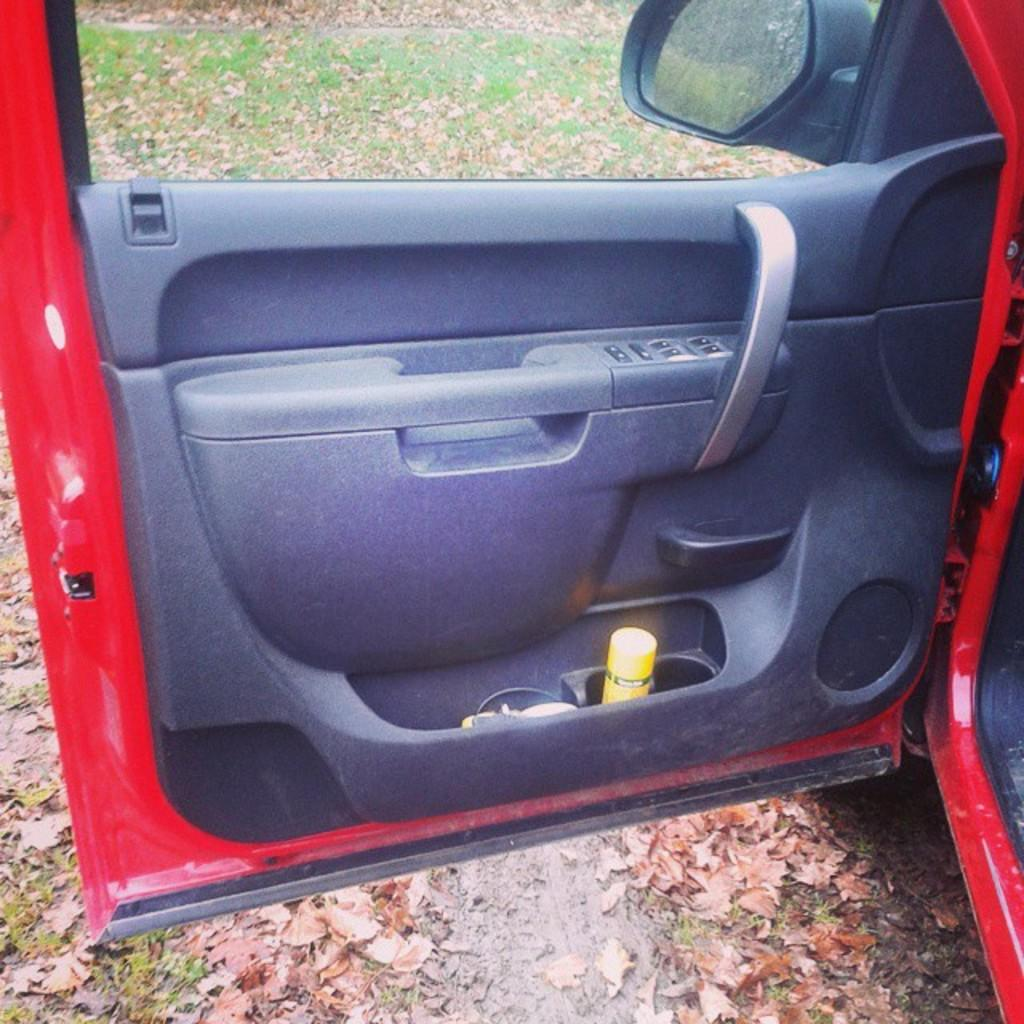What color is the car door in the image? The car door in the image is red. What is on the car door? There is spray on the car door, and there are other items on it as well. What can be seen in the background of the image? There is a side mirror and another door visible in the background. How many cards are needed to purchase the ticket for the amount shown on the car door? There are no cards, tickets, or amounts mentioned or depicted on the car door in the image. 